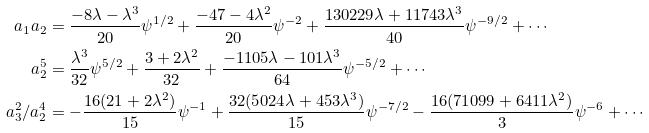<formula> <loc_0><loc_0><loc_500><loc_500>a _ { 1 } a _ { 2 } & = \frac { - 8 \lambda - \lambda ^ { 3 } } { 2 0 } \psi ^ { 1 / 2 } + \frac { - 4 7 - 4 \lambda ^ { 2 } } { 2 0 } \psi ^ { - 2 } + \frac { 1 3 0 2 2 9 \lambda + 1 1 7 4 3 \lambda ^ { 3 } } { 4 0 } \psi ^ { - 9 / 2 } + \cdots \\ a _ { 2 } ^ { 5 } & = \frac { \lambda ^ { 3 } } { 3 2 } \psi ^ { 5 / 2 } + \frac { 3 + 2 \lambda ^ { 2 } } { 3 2 } + \frac { - 1 1 0 5 \lambda - 1 0 1 \lambda ^ { 3 } } { 6 4 } \psi ^ { - 5 / 2 } + \cdots \\ a _ { 3 } ^ { 2 } / a _ { 2 } ^ { 4 } & = - \frac { 1 6 ( 2 1 + 2 \lambda ^ { 2 } ) } { 1 5 } \psi ^ { - 1 } + \frac { 3 2 ( 5 0 2 4 \lambda + 4 5 3 \lambda ^ { 3 } ) } { 1 5 } \psi ^ { - 7 / 2 } - \frac { 1 6 ( 7 1 0 9 9 + 6 4 1 1 \lambda ^ { 2 } ) } { 3 } \psi ^ { - 6 } + \cdots</formula> 